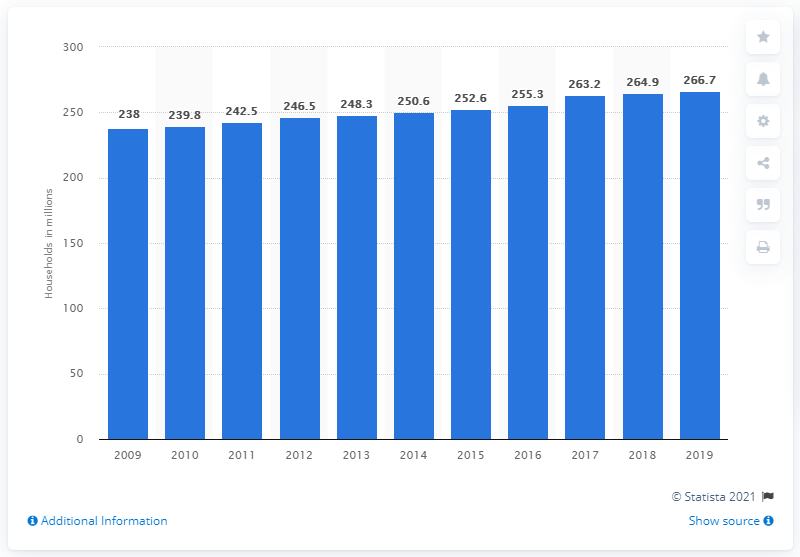List a handful of essential elements in this visual. In 2019, there were 266.7 million TV-owning households in Europe. 